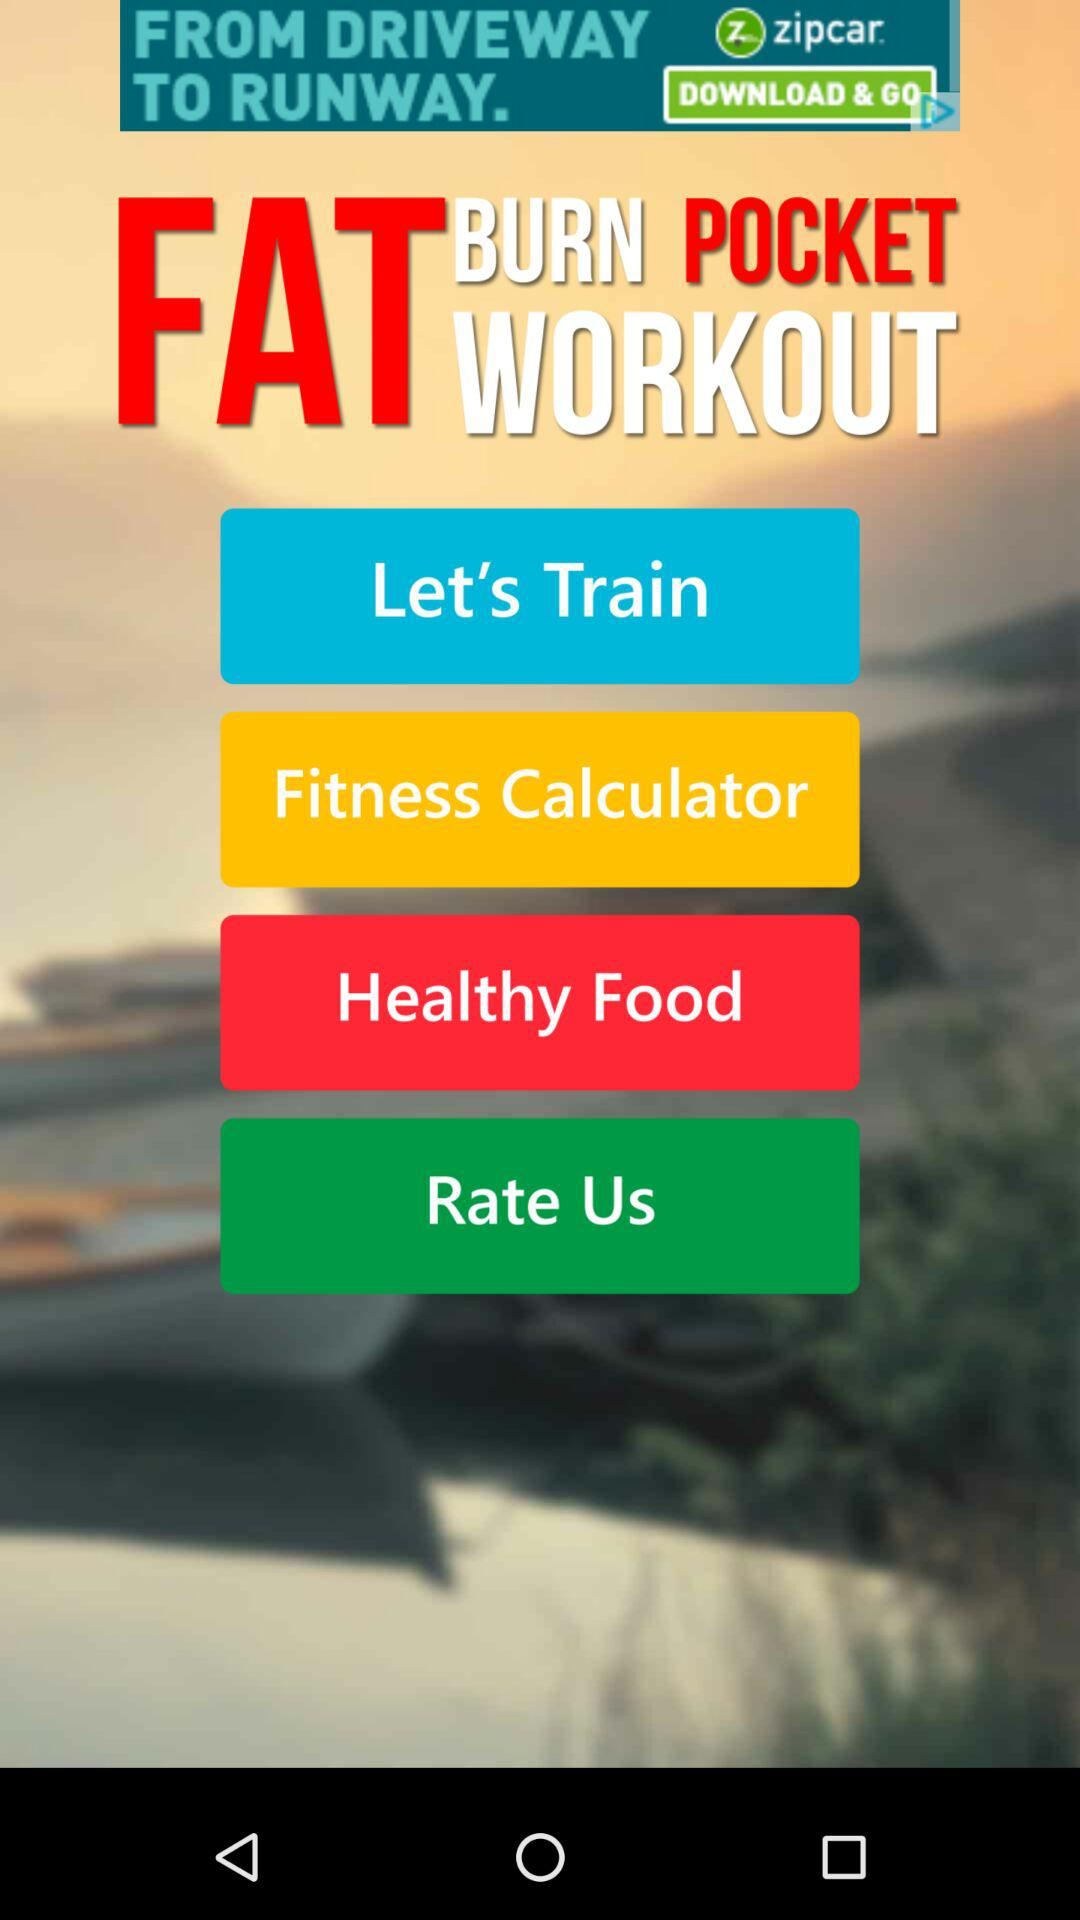What are the options available on the Fat Burn Pocket workout? The available options are: "Let's Train", "Fitness Calculator", "Healthy Food", and "Rate Us". 